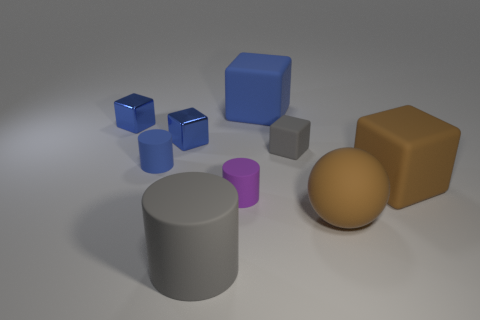Subtract all cyan balls. How many blue cubes are left? 3 Subtract 1 blocks. How many blocks are left? 4 Subtract all green cubes. Subtract all red spheres. How many cubes are left? 5 Add 1 big red spheres. How many objects exist? 10 Subtract all cylinders. How many objects are left? 6 Add 4 small purple cylinders. How many small purple cylinders exist? 5 Subtract 0 brown cylinders. How many objects are left? 9 Subtract all tiny blue matte cubes. Subtract all spheres. How many objects are left? 8 Add 1 tiny blocks. How many tiny blocks are left? 4 